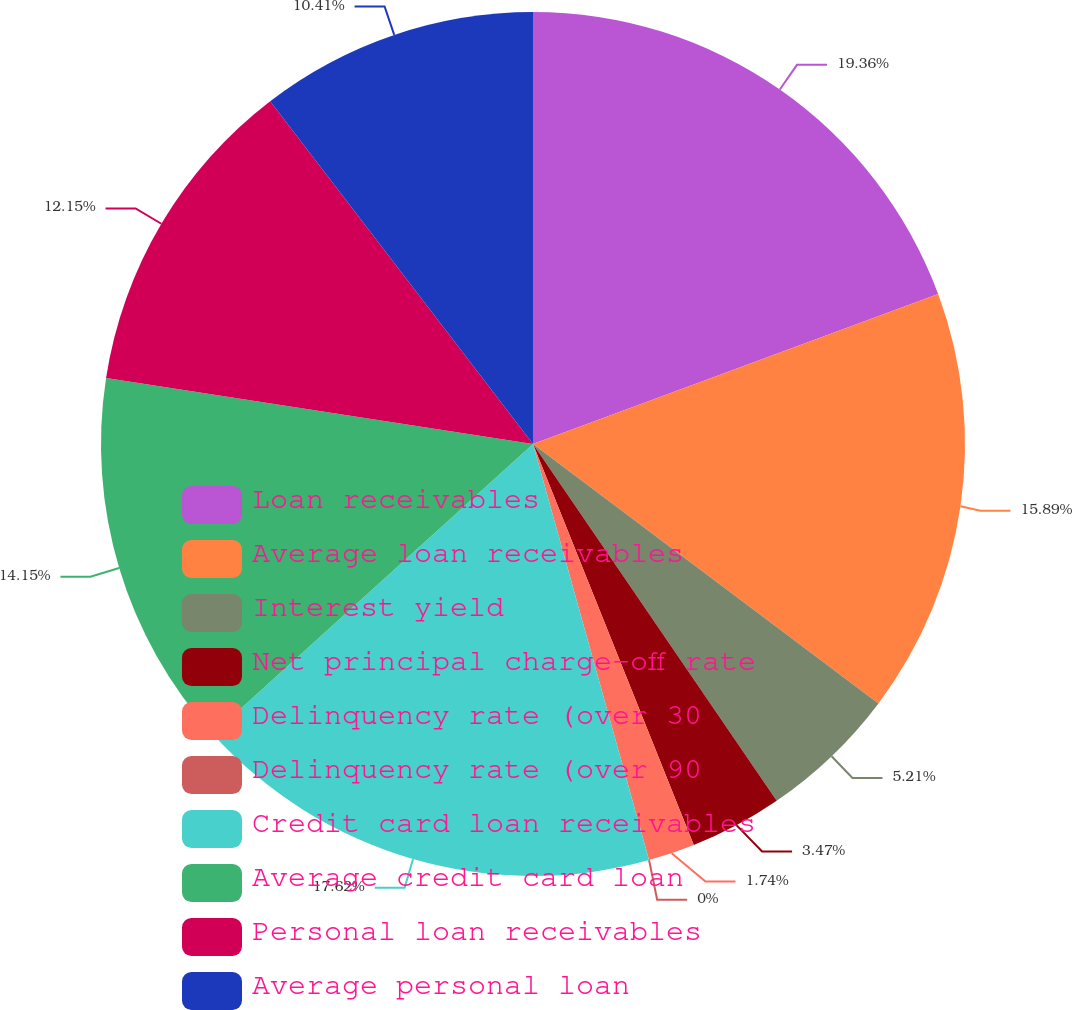Convert chart to OTSL. <chart><loc_0><loc_0><loc_500><loc_500><pie_chart><fcel>Loan receivables<fcel>Average loan receivables<fcel>Interest yield<fcel>Net principal charge-off rate<fcel>Delinquency rate (over 30<fcel>Delinquency rate (over 90<fcel>Credit card loan receivables<fcel>Average credit card loan<fcel>Personal loan receivables<fcel>Average personal loan<nl><fcel>19.36%<fcel>15.89%<fcel>5.21%<fcel>3.47%<fcel>1.74%<fcel>0.0%<fcel>17.62%<fcel>14.15%<fcel>12.15%<fcel>10.41%<nl></chart> 